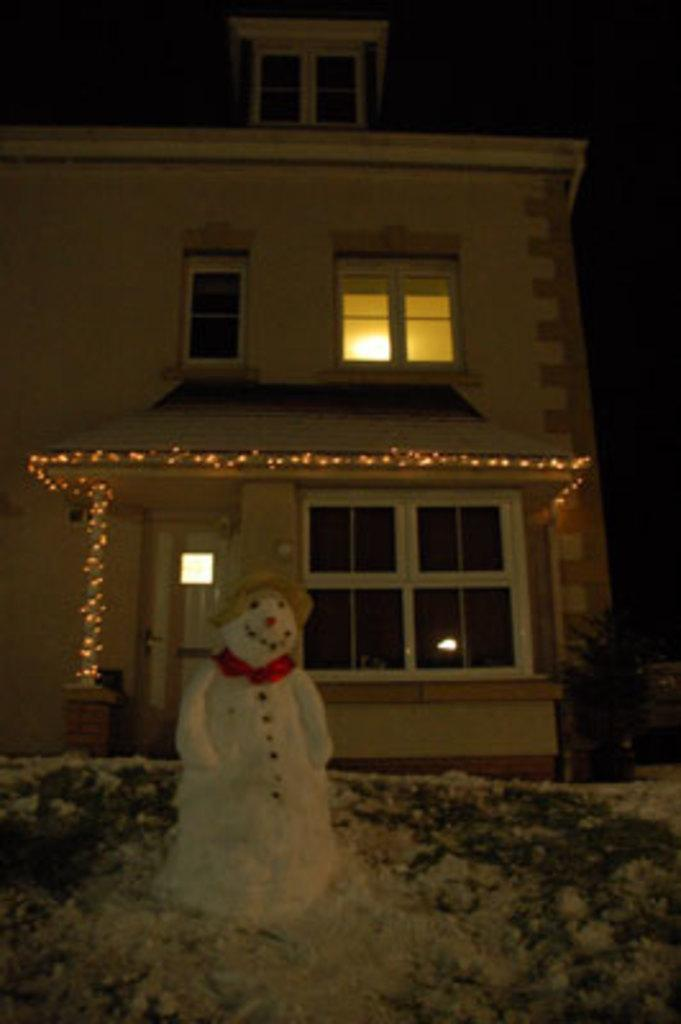What is the main subject in the foreground of the image? There is a snowman on the ground at the bottom of the image. What can be seen behind the snowman? There is a building behind the snowman. Can you describe the building in the image? The building has walls, windows, doors, and lights. What is the color of the background in the image? The background of the image is dark. What type of fang can be seen on the snowman in the image? There are no fangs present on the snowman in the image, as it is a snowman and not an animal. 